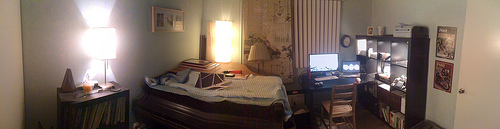What's on top of the desk near the monitor? On the desk near the monitor, there are several items including a keyboard, a mouse, what could be a docking station or external hard drive, various papers or notebooks, and potentially personal items like a phone or a pair of glasses, indicating an active workspace. Does the desk seem organized? The desk has a lived-in feel with items arranged to prioritize practicality. While it isn't sparsely organized, the placement suggests a workflow catered to the user's needs, balancing functionality over minimalist order. 